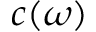Convert formula to latex. <formula><loc_0><loc_0><loc_500><loc_500>c ( \omega )</formula> 